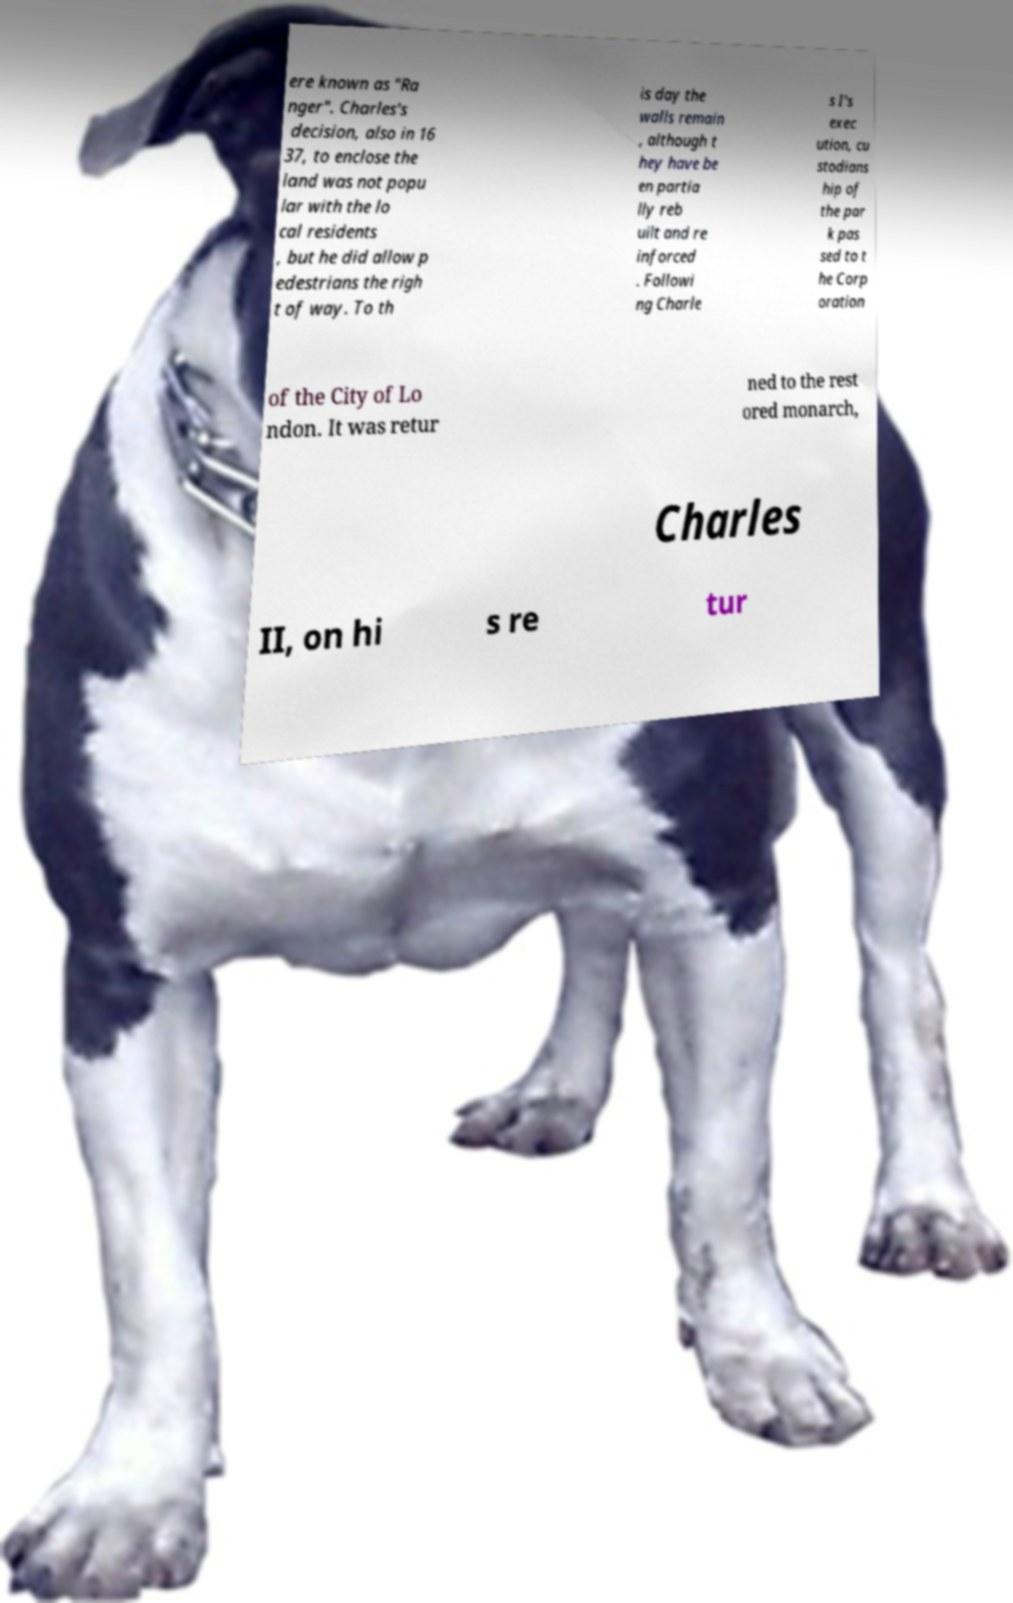I need the written content from this picture converted into text. Can you do that? ere known as "Ra nger". Charles's decision, also in 16 37, to enclose the land was not popu lar with the lo cal residents , but he did allow p edestrians the righ t of way. To th is day the walls remain , although t hey have be en partia lly reb uilt and re inforced . Followi ng Charle s I's exec ution, cu stodians hip of the par k pas sed to t he Corp oration of the City of Lo ndon. It was retur ned to the rest ored monarch, Charles II, on hi s re tur 